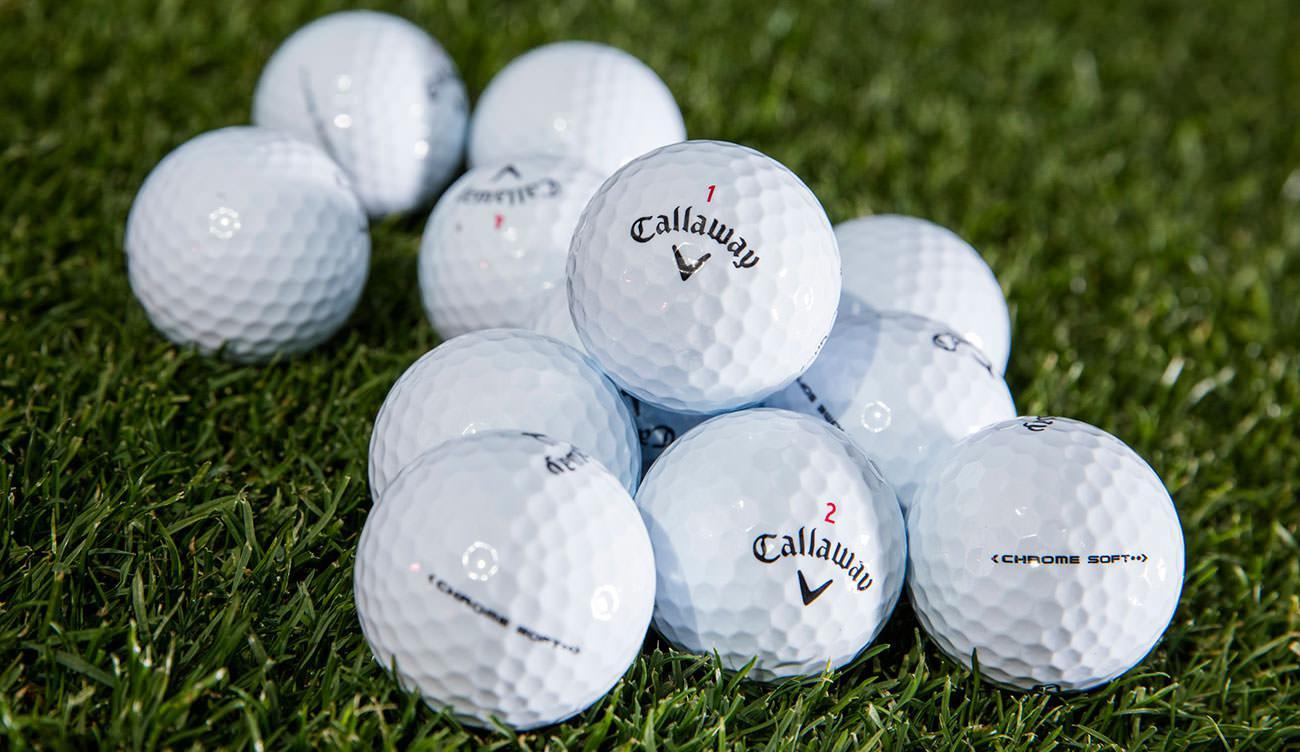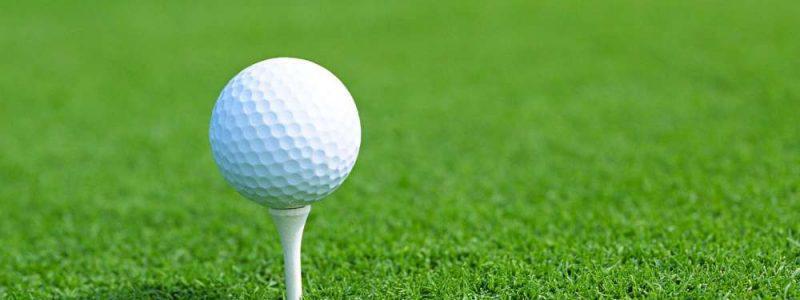The first image is the image on the left, the second image is the image on the right. Examine the images to the left and right. Is the description "All golf balls are sitting on tees in grassy areas." accurate? Answer yes or no. No. 